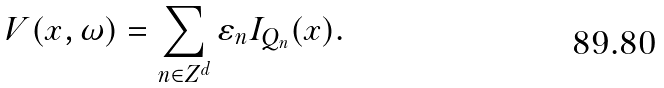<formula> <loc_0><loc_0><loc_500><loc_500>V ( x , \omega ) = \sum _ { n \in Z ^ { d } } \varepsilon _ { n } I _ { Q _ { n } } ( x ) .</formula> 